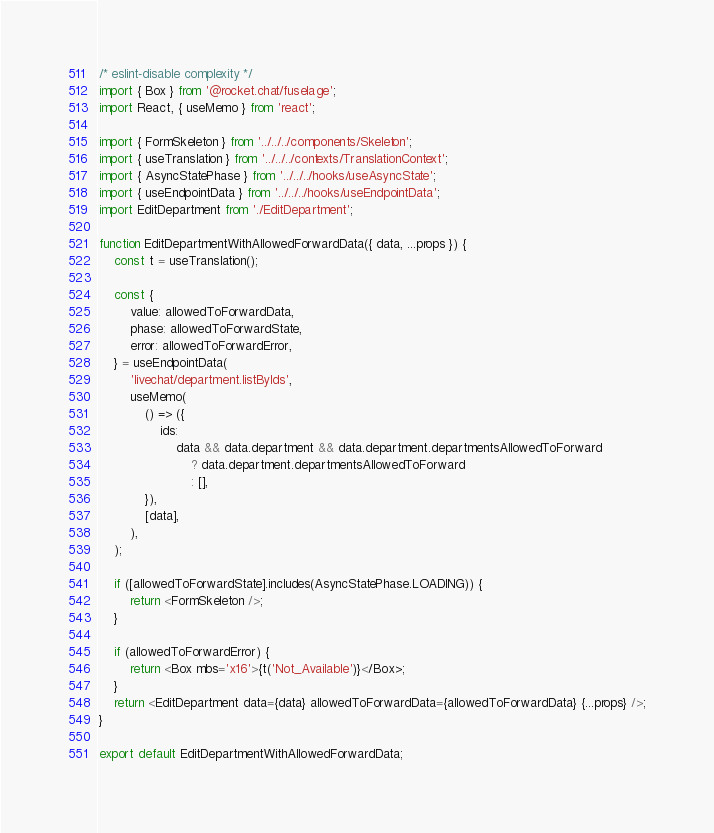Convert code to text. <code><loc_0><loc_0><loc_500><loc_500><_JavaScript_>/* eslint-disable complexity */
import { Box } from '@rocket.chat/fuselage';
import React, { useMemo } from 'react';

import { FormSkeleton } from '../../../components/Skeleton';
import { useTranslation } from '../../../contexts/TranslationContext';
import { AsyncStatePhase } from '../../../hooks/useAsyncState';
import { useEndpointData } from '../../../hooks/useEndpointData';
import EditDepartment from './EditDepartment';

function EditDepartmentWithAllowedForwardData({ data, ...props }) {
	const t = useTranslation();

	const {
		value: allowedToForwardData,
		phase: allowedToForwardState,
		error: allowedToForwardError,
	} = useEndpointData(
		'livechat/department.listByIds',
		useMemo(
			() => ({
				ids:
					data && data.department && data.department.departmentsAllowedToForward
						? data.department.departmentsAllowedToForward
						: [],
			}),
			[data],
		),
	);

	if ([allowedToForwardState].includes(AsyncStatePhase.LOADING)) {
		return <FormSkeleton />;
	}

	if (allowedToForwardError) {
		return <Box mbs='x16'>{t('Not_Available')}</Box>;
	}
	return <EditDepartment data={data} allowedToForwardData={allowedToForwardData} {...props} />;
}

export default EditDepartmentWithAllowedForwardData;
</code> 